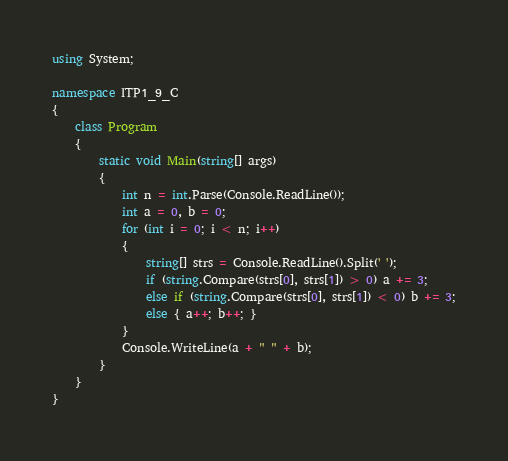<code> <loc_0><loc_0><loc_500><loc_500><_C#_>using System;

namespace ITP1_9_C
{
    class Program
    {
        static void Main(string[] args)
        {
            int n = int.Parse(Console.ReadLine());
            int a = 0, b = 0;
            for (int i = 0; i < n; i++)
            {
                string[] strs = Console.ReadLine().Split(' ');
                if (string.Compare(strs[0], strs[1]) > 0) a += 3;
                else if (string.Compare(strs[0], strs[1]) < 0) b += 3;
                else { a++; b++; }
            }
            Console.WriteLine(a + " " + b);
        }
    }
}</code> 